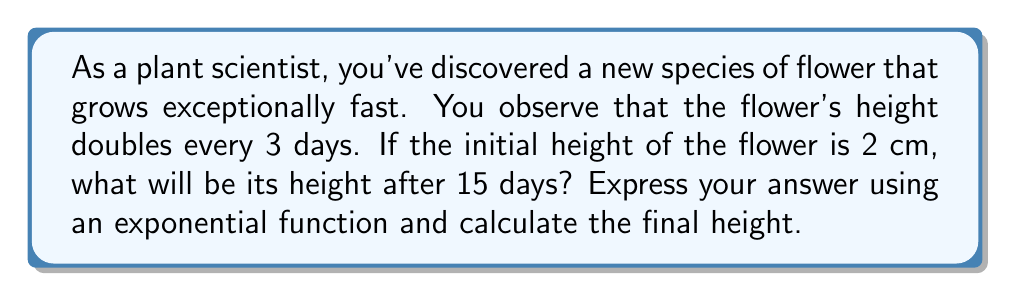What is the answer to this math problem? To solve this problem, we'll use an exponential growth function. The general form of an exponential growth function is:

$$A(t) = A_0 \cdot b^t$$

Where:
$A(t)$ is the amount at time $t$
$A_0$ is the initial amount
$b$ is the growth factor
$t$ is the time

In this case:
$A_0 = 2$ cm (initial height)
The height doubles every 3 days, so we need to find $b$ such that $b^3 = 2$
$b = \sqrt[3]{2} \approx 1.2599$
$t = 15$ days

Now, we need to adjust our function because the doubling occurs every 3 days, not every day. We'll divide $t$ by 3:

$$A(t) = 2 \cdot (\sqrt[3]{2})^{t/3}$$

Substituting $t = 15$:

$$A(15) = 2 \cdot (\sqrt[3]{2})^{15/3} = 2 \cdot (\sqrt[3]{2})^5$$

To calculate the final value:

$$A(15) = 2 \cdot (2^{5/3}) = 2 \cdot 2^{1.6667} \approx 6.35 \text{ cm}$$
Answer: The height of the flower after 15 days can be expressed as $A(15) = 2 \cdot (\sqrt[3]{2})^5$ cm, which is approximately 6.35 cm. 